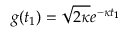<formula> <loc_0><loc_0><loc_500><loc_500>g ( t _ { 1 } ) = \sqrt { 2 \kappa } e ^ { - \kappa t _ { 1 } }</formula> 